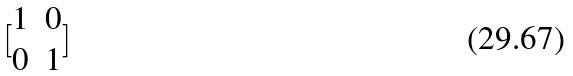Convert formula to latex. <formula><loc_0><loc_0><loc_500><loc_500>[ \begin{matrix} 1 & 0 \\ 0 & 1 \end{matrix} ]</formula> 